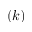Convert formula to latex. <formula><loc_0><loc_0><loc_500><loc_500>( k )</formula> 